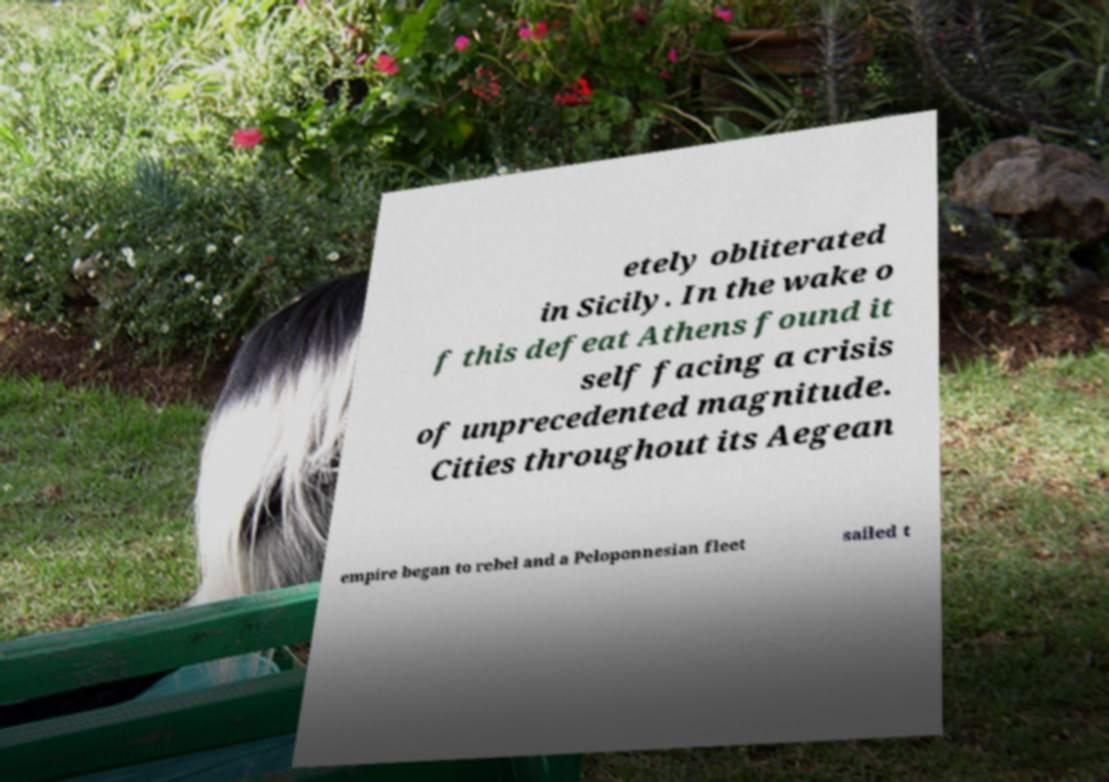There's text embedded in this image that I need extracted. Can you transcribe it verbatim? etely obliterated in Sicily. In the wake o f this defeat Athens found it self facing a crisis of unprecedented magnitude. Cities throughout its Aegean empire began to rebel and a Peloponnesian fleet sailed t 